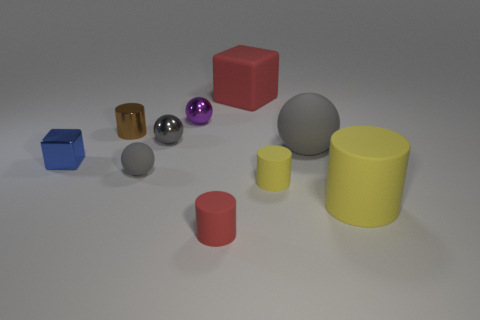Subtract all gray balls. How many were subtracted if there are1gray balls left? 2 Subtract all purple cubes. How many gray balls are left? 3 Subtract 1 balls. How many balls are left? 3 Subtract all spheres. How many objects are left? 6 Subtract all purple metal cubes. Subtract all gray things. How many objects are left? 7 Add 1 big gray things. How many big gray things are left? 2 Add 8 big metal balls. How many big metal balls exist? 8 Subtract 2 gray spheres. How many objects are left? 8 